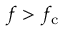Convert formula to latex. <formula><loc_0><loc_0><loc_500><loc_500>f > f _ { c }</formula> 